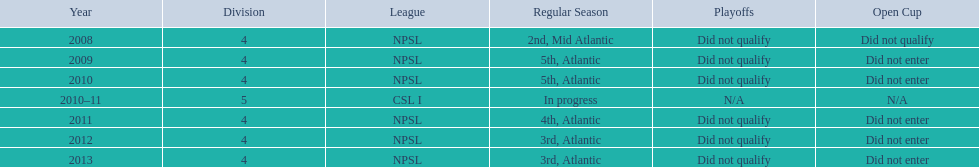What are the names of the leagues? NPSL, CSL I. Which league other than npsl did ny soccer team play under? CSL I. 